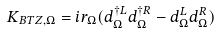Convert formula to latex. <formula><loc_0><loc_0><loc_500><loc_500>K _ { B T Z , \Omega } = i r _ { \Omega } ( d _ { \Omega } ^ { \dagger L } d _ { \Omega } ^ { \dagger R } - d _ { \Omega } ^ { L } d _ { \Omega } ^ { R } )</formula> 